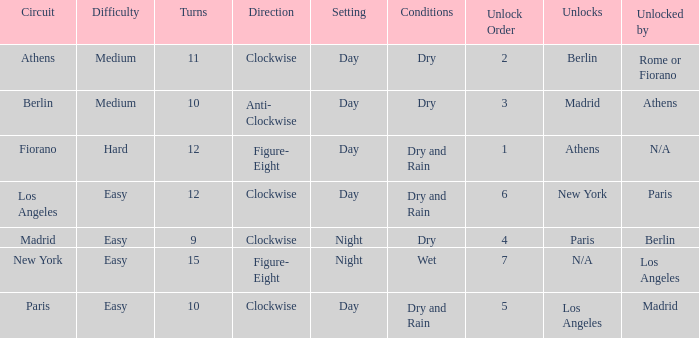What are the prerequisites for the athens circuit? Dry. 